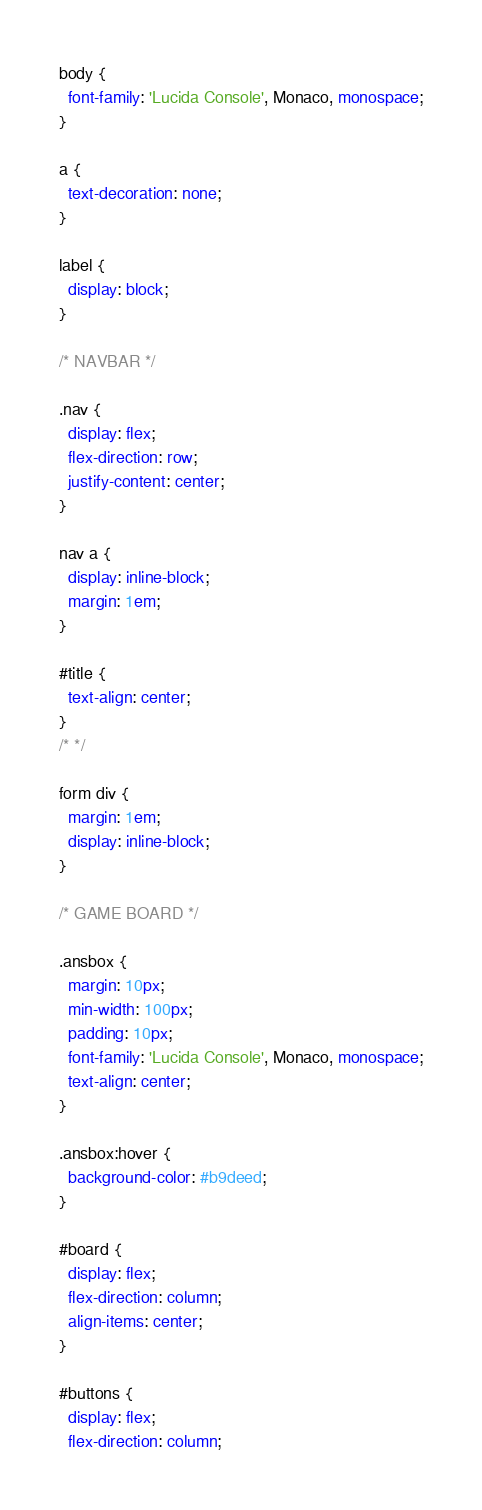Convert code to text. <code><loc_0><loc_0><loc_500><loc_500><_CSS_>body {
  font-family: 'Lucida Console', Monaco, monospace;
}

a {
  text-decoration: none;
}

label {
  display: block;
}

/* NAVBAR */

.nav {
  display: flex;
  flex-direction: row;
  justify-content: center;
}

nav a {
  display: inline-block;
  margin: 1em;
}

#title {
  text-align: center;
}
/* */

form div {
  margin: 1em;
  display: inline-block;
}

/* GAME BOARD */

.ansbox {
  margin: 10px;
  min-width: 100px;
  padding: 10px;
  font-family: 'Lucida Console', Monaco, monospace;
  text-align: center;
}

.ansbox:hover {
  background-color: #b9deed;
}

#board {
  display: flex;
  flex-direction: column;
  align-items: center;
}

#buttons {
  display: flex;
  flex-direction: column;</code> 